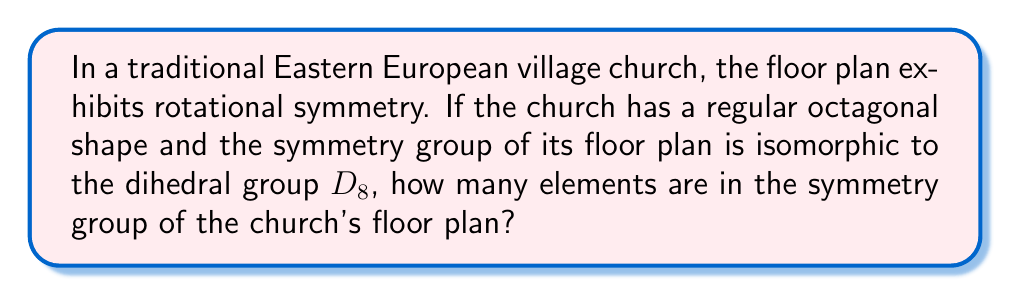Give your solution to this math problem. Let's approach this step-by-step:

1) The dihedral group $D_n$ is the group of symmetries of a regular n-gon. In this case, we have $D_8$, which corresponds to the symmetries of a regular octagon.

2) The elements of $D_8$ consist of:
   - The identity element (no rotation or reflection)
   - Rotations by multiples of $\frac{2\pi}{8} = \frac{\pi}{4}$ radians
   - Reflections across the 8 axes of symmetry

3) To count the elements:
   - Rotations: There are 8 rotations (including the identity), as we can rotate by 0, $\frac{\pi}{4}$, $\frac{\pi}{2}$, $\frac{3\pi}{4}$, $\pi$, $\frac{5\pi}{4}$, $\frac{3\pi}{2}$, and $\frac{7\pi}{4}$.
   - Reflections: There are 8 axes of symmetry in a regular octagon (4 through opposite vertices and 4 through the midpoints of opposite sides).

4) The total number of elements in $D_8$ is therefore:
   $$\text{Number of elements} = \text{Number of rotations} + \text{Number of reflections}$$
   $$\text{Number of elements} = 8 + 8 = 16$$

Therefore, the symmetry group of the church's floor plan has 16 elements.
Answer: 16 